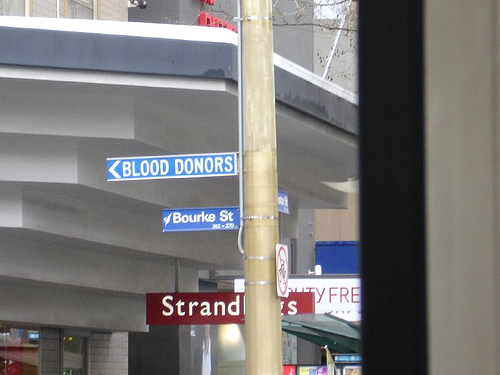Extract all visible text content from this image. BLOOD DONORS Bourke St strand S TY FRE 